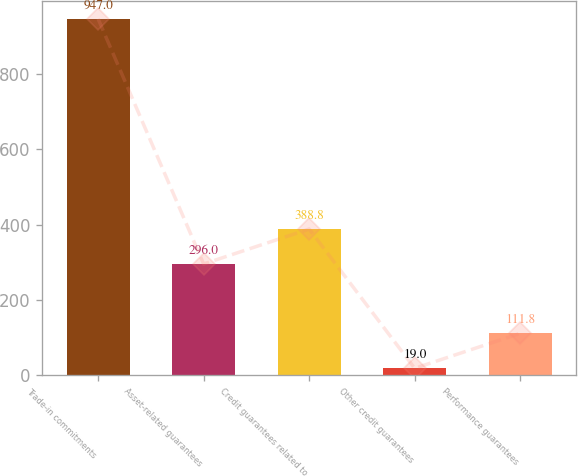Convert chart. <chart><loc_0><loc_0><loc_500><loc_500><bar_chart><fcel>Trade-in commitments<fcel>Asset-related guarantees<fcel>Credit guarantees related to<fcel>Other credit guarantees<fcel>Performance guarantees<nl><fcel>947<fcel>296<fcel>388.8<fcel>19<fcel>111.8<nl></chart> 